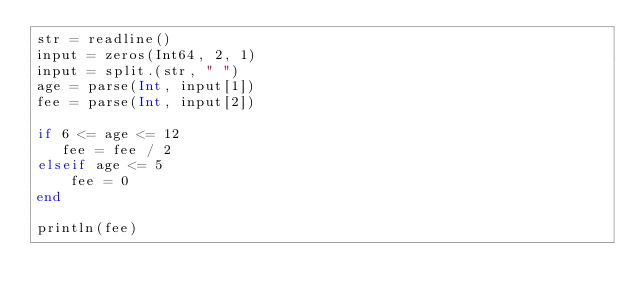Convert code to text. <code><loc_0><loc_0><loc_500><loc_500><_Julia_>str = readline()
input = zeros(Int64, 2, 1) 
input = split.(str, " ")
age = parse(Int, input[1])
fee = parse(Int, input[2])

if 6 <= age <= 12
   fee = fee / 2
elseif age <= 5
    fee = 0
end

println(fee)</code> 